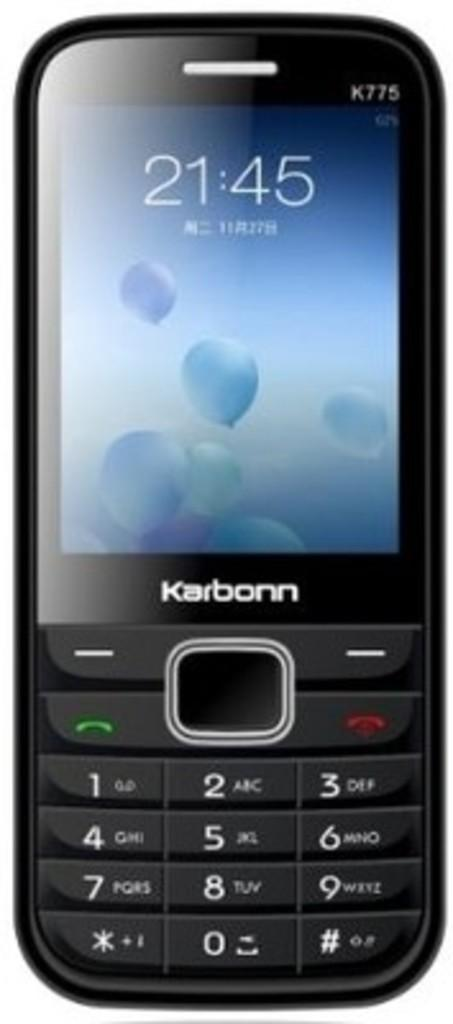<image>
Write a terse but informative summary of the picture. A Karbonn cell phone that has the time as 21:45. 